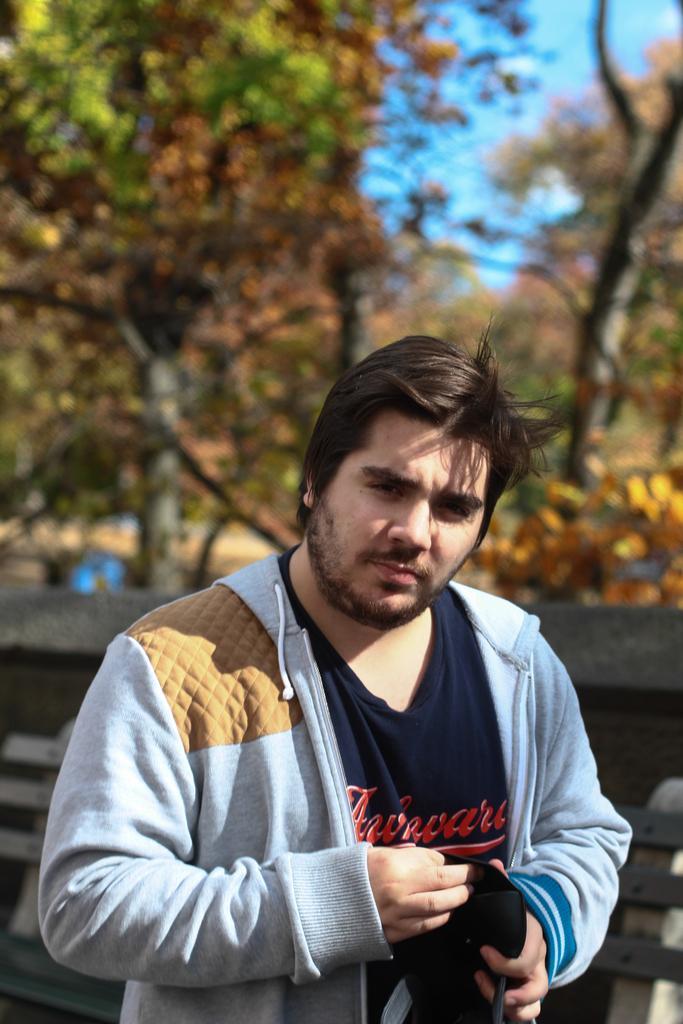Can you describe this image briefly? In this image we can see a man and behind him we can see trees and sky. 